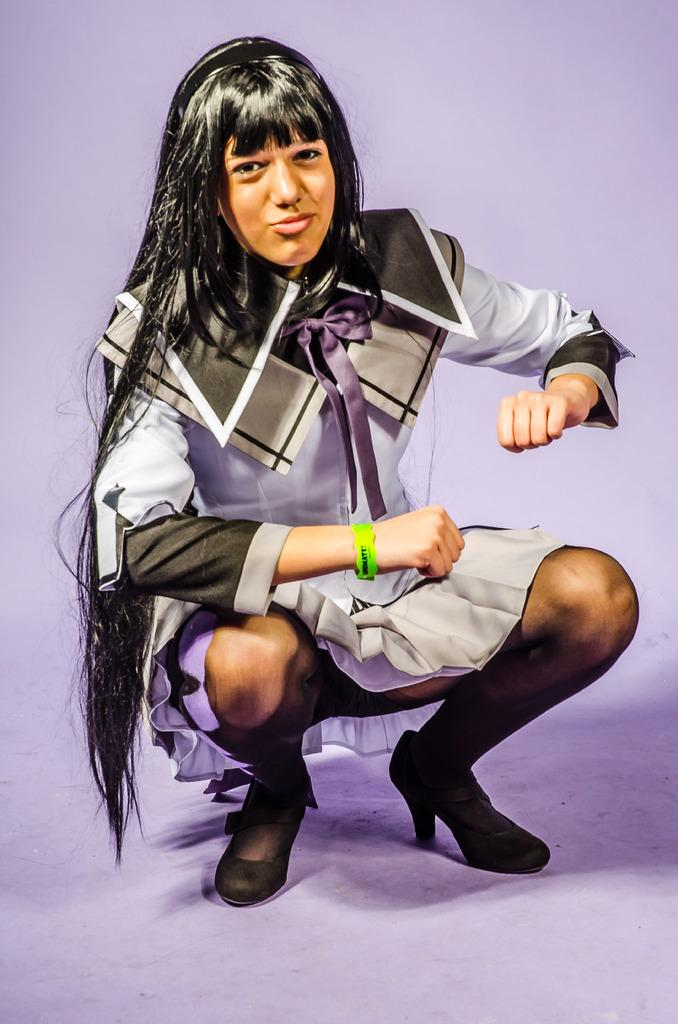What is the main subject of the image? There is a person in the image. What is the person wearing? The person is wearing a different costume. What is the person's facial expression? The person is smiling. What position is the person in? The person is in a squat position. What color is the background of the image? The background of the image is in violet color. Can you see any matches in the image? There are no matches present in the image. Is there an owl in the image? There is no owl present in the image. 